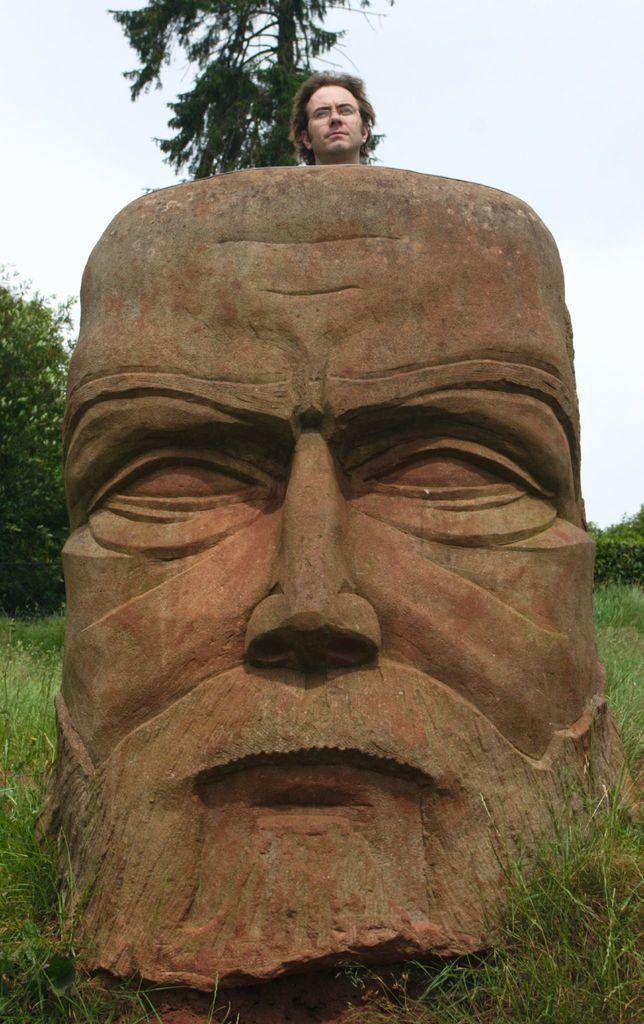Who is present in the image? There is a man in the image. What is the man doing in the image? The man is standing behind a statue of a face. What can be seen in the background of the image? There are trees in the background of the image. What type of environment is the image set in? The trees are on a grassland, and the sky is visible above the grassland. What type of cake is being served at the school in the image? There is no cake or school present in the image; it features a man standing behind a statue of a face with trees, grassland, and sky in the background. 